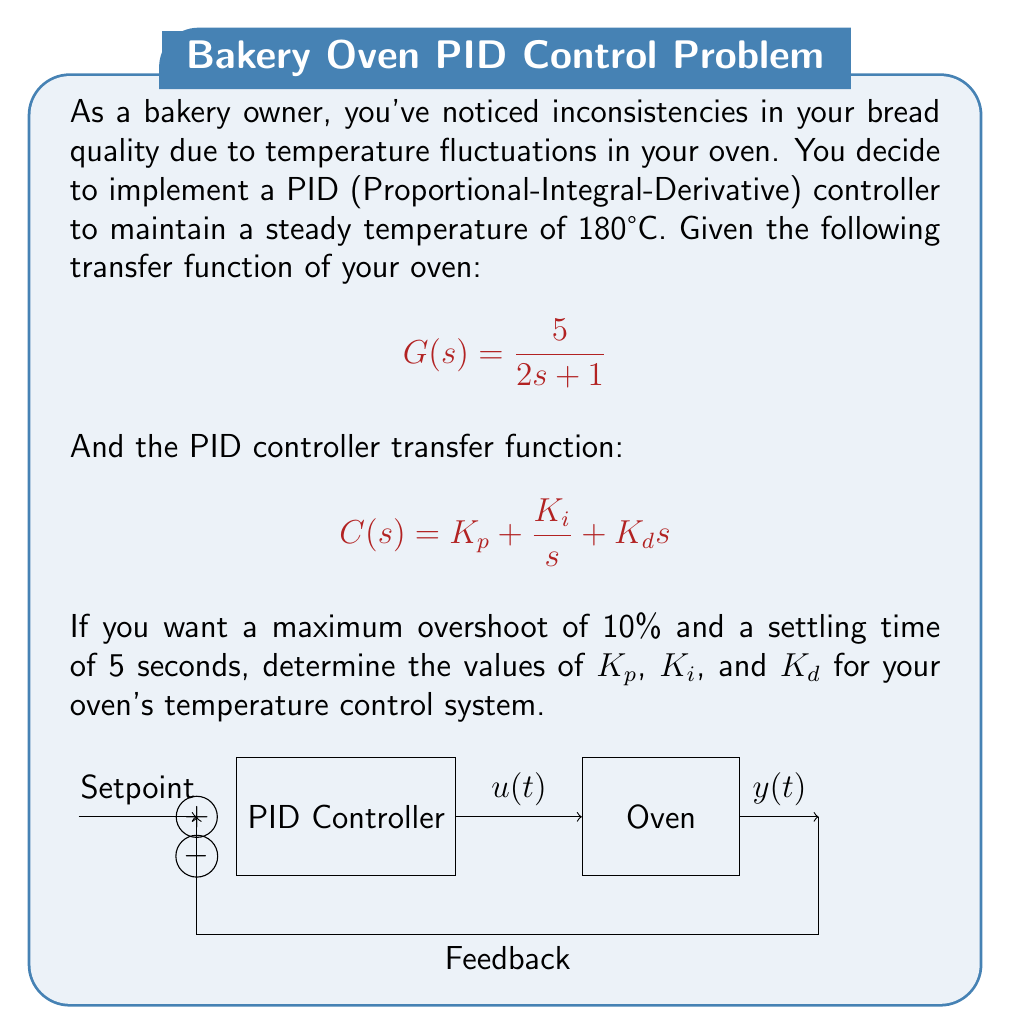Solve this math problem. To solve this problem, we'll use the second-order approximation method:

1. The closed-loop transfer function is:
   $$T(s) = \frac{G(s)C(s)}{1 + G(s)C(s)} = \frac{5(K_p s + K_i + K_d s^2)}{2s^2 + (5K_d + 1)s + 5K_p}$$

2. Comparing with the standard second-order form:
   $$\frac{\omega_n^2}{s^2 + 2\zeta\omega_n s + \omega_n^2}$$

   We get: $\omega_n^2 = \frac{5K_p}{2}$ and $2\zeta\omega_n = \frac{5K_d + 1}{2}$

3. For 10% overshoot, $\zeta = 0.591$
   For 5 seconds settling time, $\omega_n = \frac{4}{5\zeta} = 1.354$

4. From $\omega_n^2 = \frac{5K_p}{2}$, we get $K_p = 0.733$

5. From $2\zeta\omega_n = \frac{5K_d + 1}{2}$, we get $K_d = 0.239$

6. For $K_i$, we use the rule of thumb: $K_i = \frac{\omega_n}{10} = 0.135$

Therefore, the PID controller parameters are:
$K_p = 0.733$, $K_i = 0.135$, and $K_d = 0.239$
Answer: $K_p = 0.733$, $K_i = 0.135$, $K_d = 0.239$ 